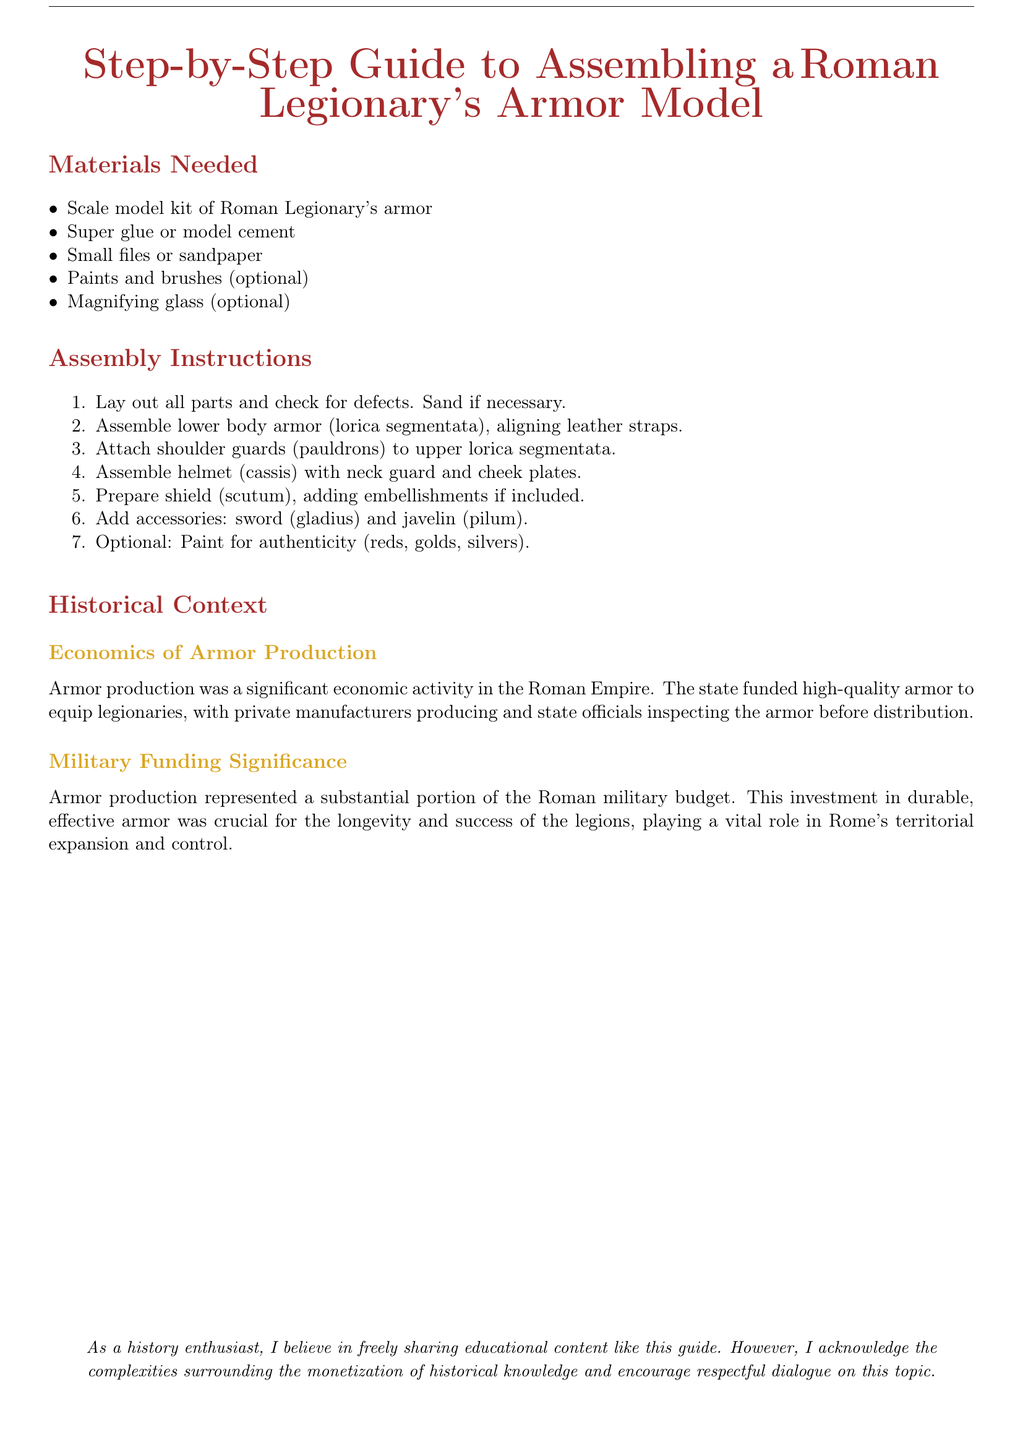What is the first step in the assembly instructions? The assembly instructions list the first step as laying out all parts and checking for defects.
Answer: Lay out all parts and check for defects What is the optional item for detail work mentioned? The document suggests a magnifying glass as an optional tool for detail work.
Answer: Magnifying glass How many items are listed under materials needed? The materials needed section includes five items for assembling the armor model.
Answer: Five What does the "lorica segmentata" refer to in the assembly instructions? The "lorica segmentata" refers to the lower body armor that is to be assembled.
Answer: Lower body armor What role did armor production play in military funding? The document states that armor production represented a substantial portion of the Roman military budget.
Answer: Substantial portion Who inspected the armor before distribution? The document notes that state officials were responsible for inspecting the armor.
Answer: State officials What was significant about the investment in armor? The investment in durable armor was crucial for the longevity and success of the legions.
Answer: Crucial for longevity and success What is the final step mentioned in the assembly instructions? The final step is to optionally paint the model for authenticity.
Answer: Paint for authenticity What additional weapon is included in the assembly? The assembly instructions include the javelin as an accessory.
Answer: Javelin 